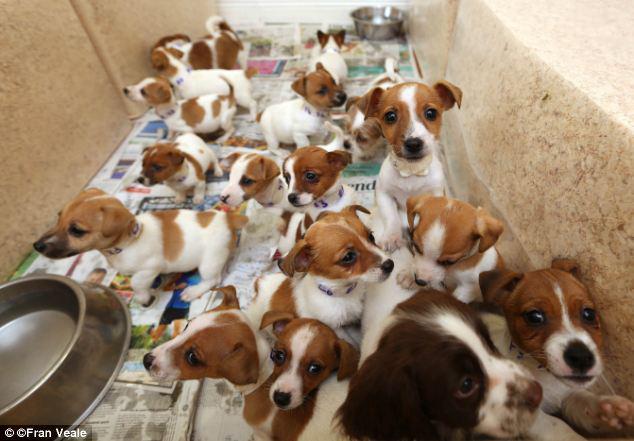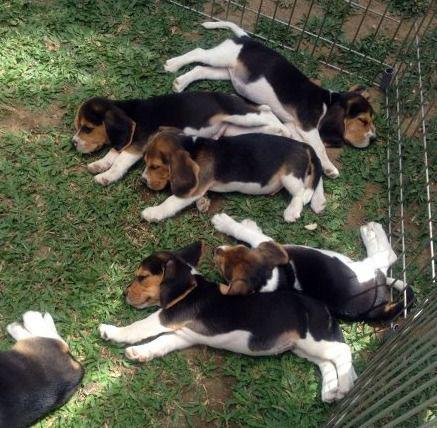The first image is the image on the left, the second image is the image on the right. Examine the images to the left and right. Is the description "There is at least one human interacting with a pack of dogs." accurate? Answer yes or no. No. The first image is the image on the left, the second image is the image on the right. Analyze the images presented: Is the assertion "A person is on the road with some of the dogs." valid? Answer yes or no. No. 